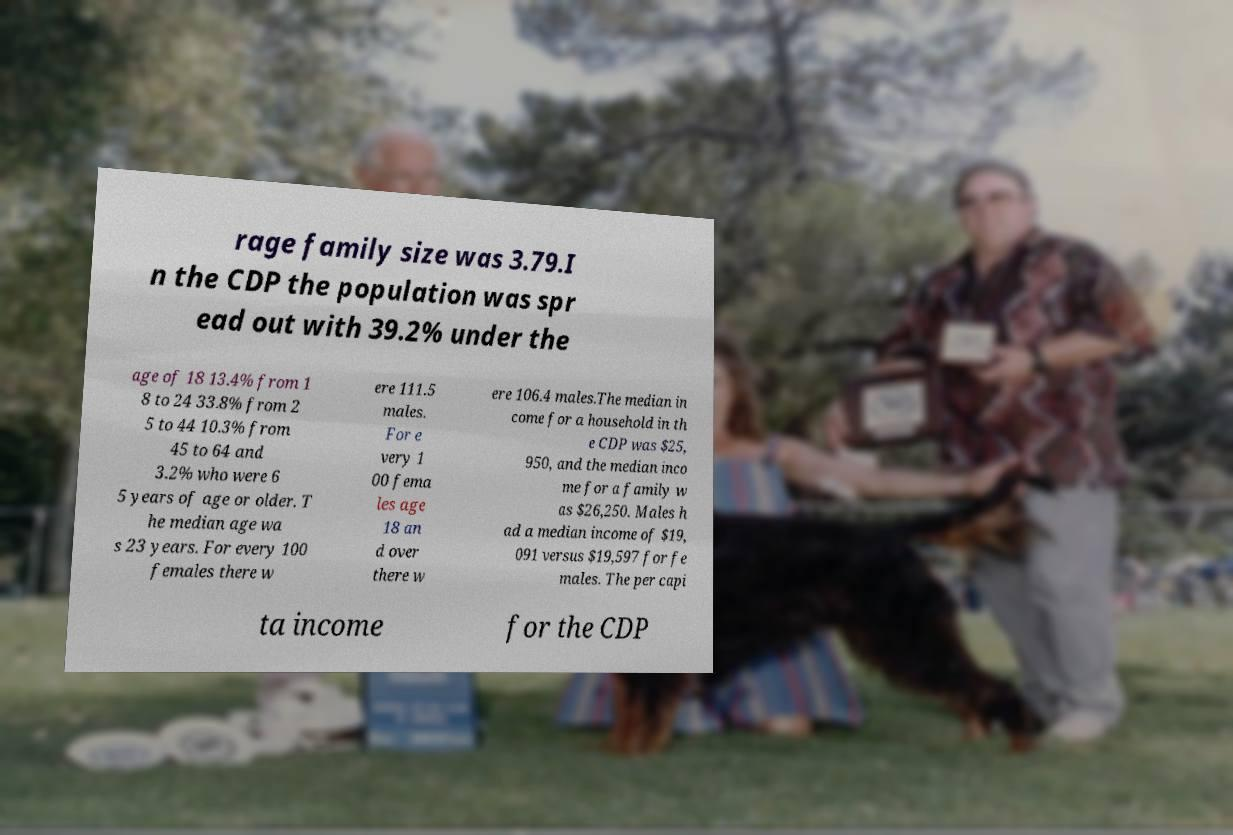Please read and relay the text visible in this image. What does it say? rage family size was 3.79.I n the CDP the population was spr ead out with 39.2% under the age of 18 13.4% from 1 8 to 24 33.8% from 2 5 to 44 10.3% from 45 to 64 and 3.2% who were 6 5 years of age or older. T he median age wa s 23 years. For every 100 females there w ere 111.5 males. For e very 1 00 fema les age 18 an d over there w ere 106.4 males.The median in come for a household in th e CDP was $25, 950, and the median inco me for a family w as $26,250. Males h ad a median income of $19, 091 versus $19,597 for fe males. The per capi ta income for the CDP 